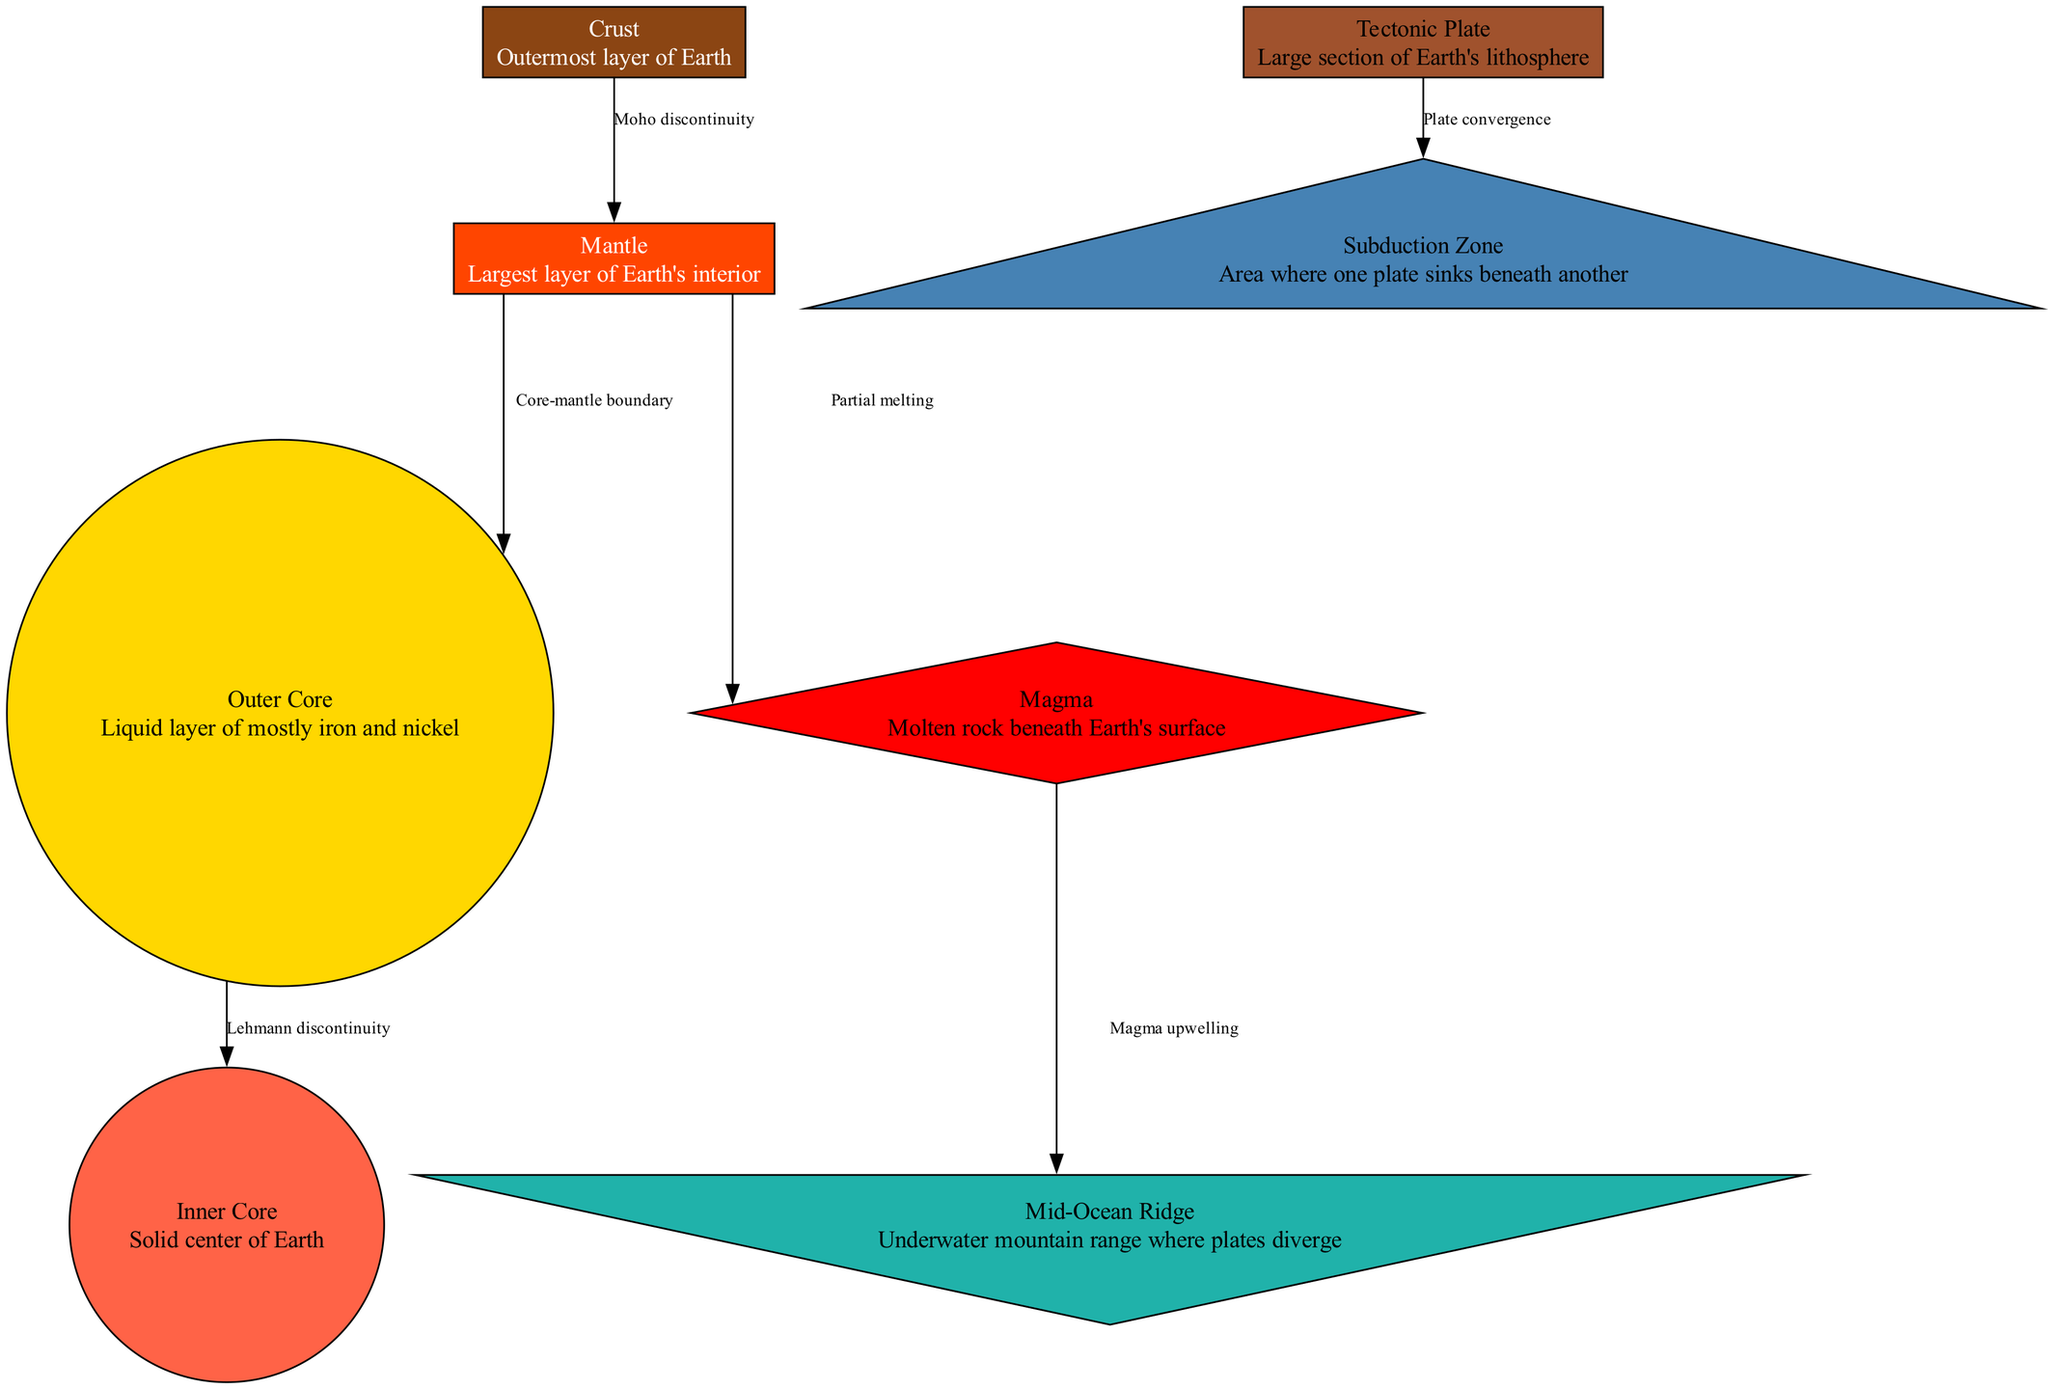What is the outermost layer of the Earth? The outermost layer, which is represented in the diagram, is labeled as the "Crust". It is explicitly stated in the node description.
Answer: Crust What is the largest layer of Earth's interior? In the diagram, the "Mantle" is labeled as the largest layer of Earth's interior, according to the node description.
Answer: Mantle How many main layers of the Earth are shown in the diagram? The diagram depicts four main layers: Crust, Mantle, Outer Core, and Inner Core. By counting the nodes representing these layers, the total is four.
Answer: 4 What is the process that occurs at the Mid-Ocean Ridge? The diagram indicates that "Magma upwelling" occurs at the Mid-Ocean Ridge, linking the magma layer to this underwater mountain range through the directed edge.
Answer: Magma upwelling What type of boundary is depicted between tectonic plates? The diagram shows a "Subduction Zone," which is an area where one plate sinks beneath another. This is identified by the edge connecting "Tectonic Plate" and "Subduction Zone".
Answer: Subduction Zone What separates the crust from the mantle? The "Moho discontinuity" is the boundary that separates the crust from the mantle, as indicated by the edge drawn from "Crust" to "Mantle".
Answer: Moho discontinuity What layer is found directly beneath the crust? According to the diagram, the layer directly beneath the crust is the "Mantle." The diagram clearly shows this relationship through the edges.
Answer: Mantle What are the materials primarily found in the outer core? The outer core is described as a liquid layer made mostly of "iron and nickel," as provided in its node description.
Answer: Iron and nickel How does magma contribute to plate tectonics according to the diagram? The "Magma upwelling" at the Mid-Ocean Ridge allows for the creation of new oceanic crust when magma rises to the surface, contributing to tectonic plate movement. This flow is illustrated in the diagram.
Answer: Magma upwelling What is the connection between the mantle and the outer core? The edge labeled "Core-mantle boundary" describes the connection between the mantle and the outer core, illustrating their spatial relationship in the diagram.
Answer: Core-mantle boundary 